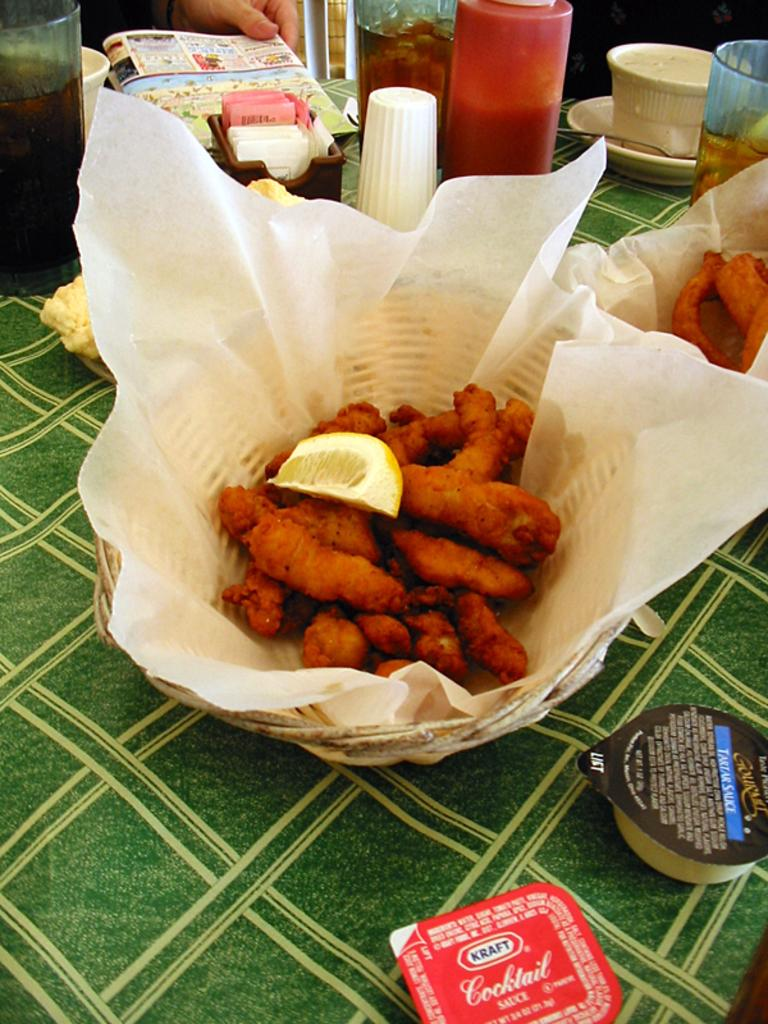Provide a one-sentence caption for the provided image. A basket of fried food with Kraft cocktail sauce and tartar sauce packets on the table nearby. 